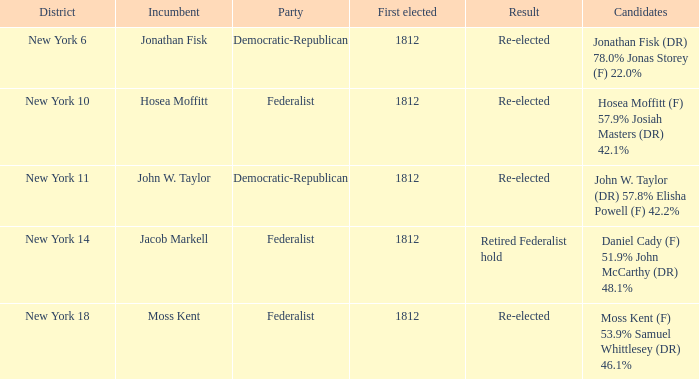Specify the most initial first elected 1812.0. 